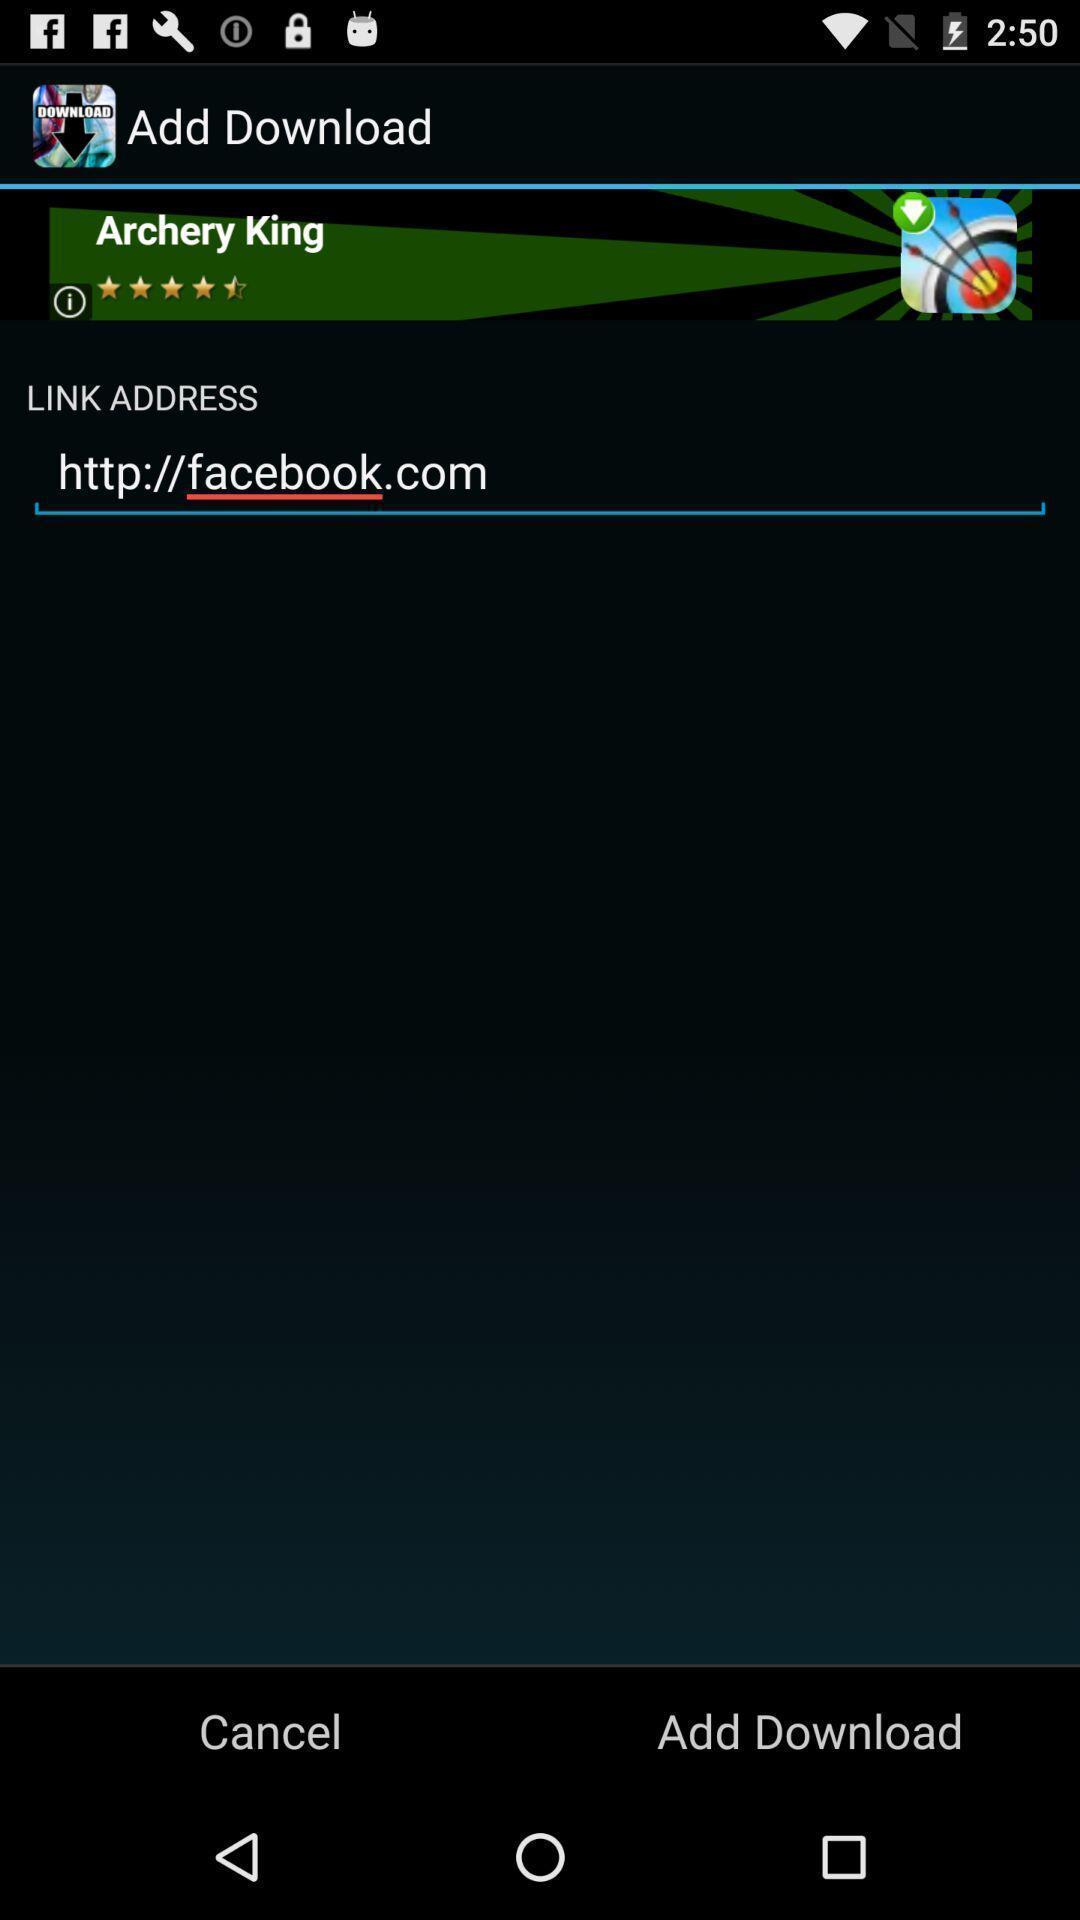Describe the visual elements of this screenshot. Screen page displaying website link and other options. 